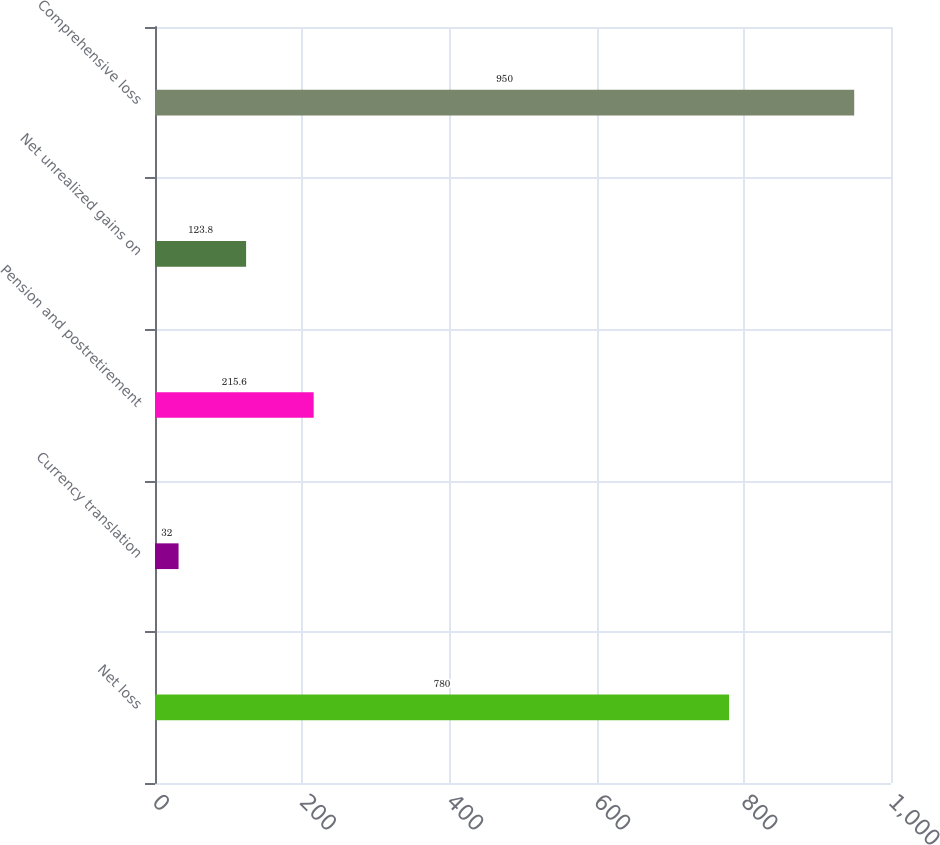Convert chart to OTSL. <chart><loc_0><loc_0><loc_500><loc_500><bar_chart><fcel>Net loss<fcel>Currency translation<fcel>Pension and postretirement<fcel>Net unrealized gains on<fcel>Comprehensive loss<nl><fcel>780<fcel>32<fcel>215.6<fcel>123.8<fcel>950<nl></chart> 